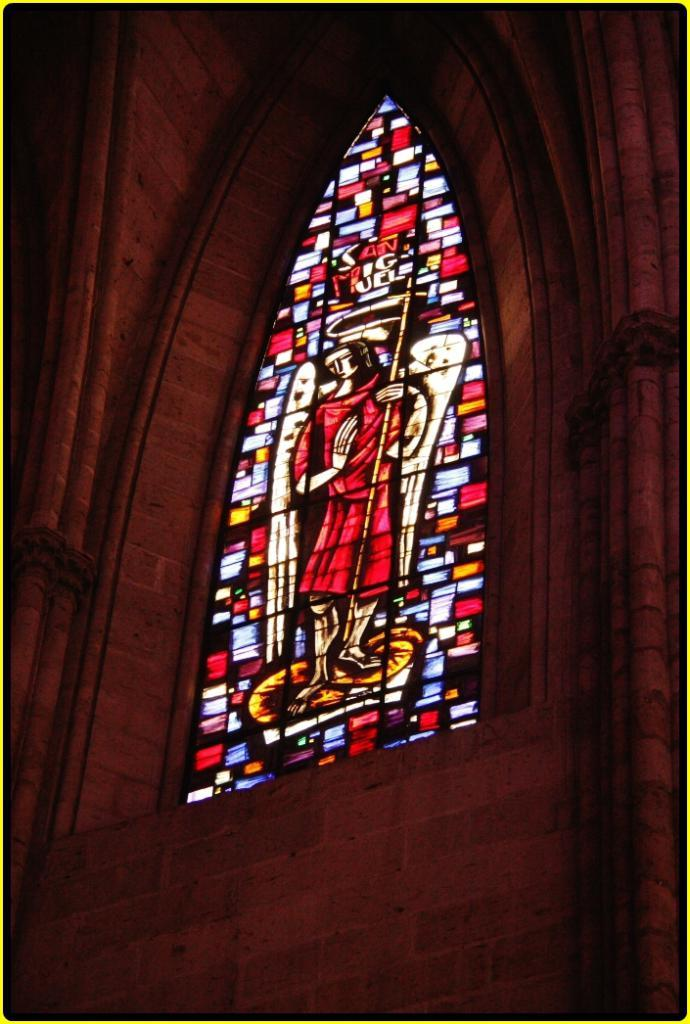What type of structure can be seen in the image? There is a wall in the image. What is a notable feature of the wall? There is a stained glass in the image. Can you see any waves crashing against the wall in the image? There are no waves present in the image; it features a wall with a stained glass. What type of emotion is depicted in the stained glass? The stained glass does not depict any specific emotion; it is a decorative element on the wall. 